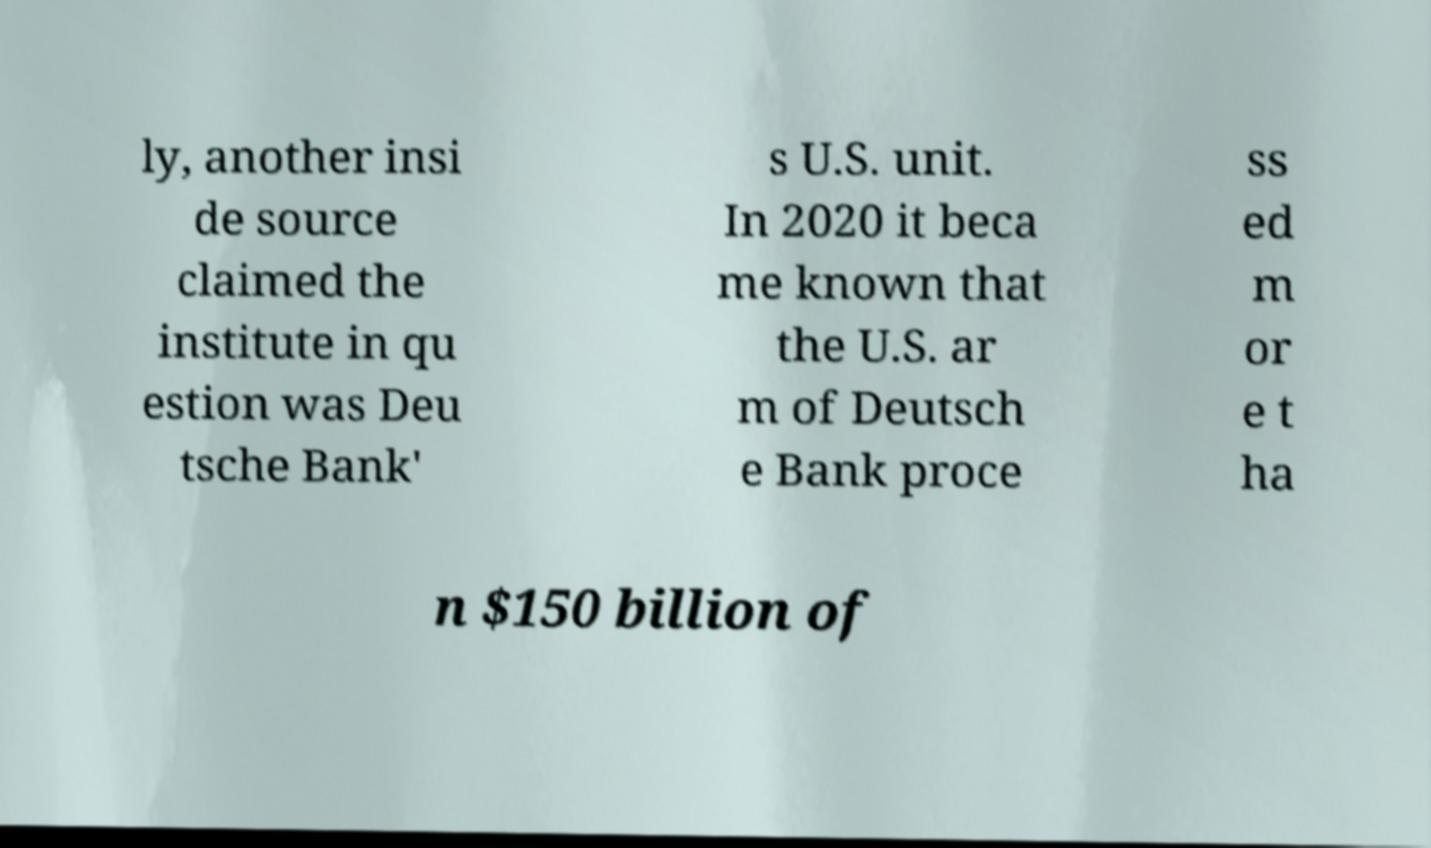Please read and relay the text visible in this image. What does it say? ly, another insi de source claimed the institute in qu estion was Deu tsche Bank' s U.S. unit. In 2020 it beca me known that the U.S. ar m of Deutsch e Bank proce ss ed m or e t ha n $150 billion of 